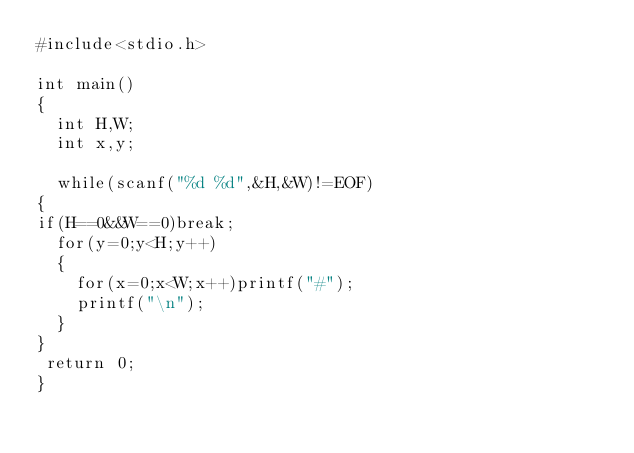<code> <loc_0><loc_0><loc_500><loc_500><_C_>#include<stdio.h>

int main()
{
  int H,W;
  int x,y;

  while(scanf("%d %d",&H,&W)!=EOF)
{
if(H==0&&W==0)break;
  for(y=0;y<H;y++)
  {
    for(x=0;x<W;x++)printf("#");
    printf("\n");
  }
}
 return 0;
}</code> 